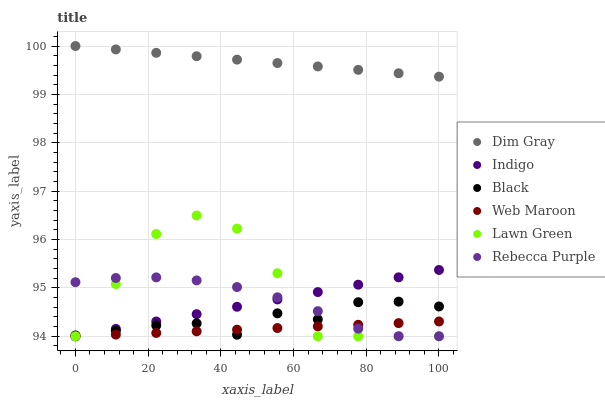Does Web Maroon have the minimum area under the curve?
Answer yes or no. Yes. Does Dim Gray have the maximum area under the curve?
Answer yes or no. Yes. Does Indigo have the minimum area under the curve?
Answer yes or no. No. Does Indigo have the maximum area under the curve?
Answer yes or no. No. Is Indigo the smoothest?
Answer yes or no. Yes. Is Lawn Green the roughest?
Answer yes or no. Yes. Is Dim Gray the smoothest?
Answer yes or no. No. Is Dim Gray the roughest?
Answer yes or no. No. Does Lawn Green have the lowest value?
Answer yes or no. Yes. Does Dim Gray have the lowest value?
Answer yes or no. No. Does Dim Gray have the highest value?
Answer yes or no. Yes. Does Indigo have the highest value?
Answer yes or no. No. Is Lawn Green less than Dim Gray?
Answer yes or no. Yes. Is Dim Gray greater than Lawn Green?
Answer yes or no. Yes. Does Black intersect Lawn Green?
Answer yes or no. Yes. Is Black less than Lawn Green?
Answer yes or no. No. Is Black greater than Lawn Green?
Answer yes or no. No. Does Lawn Green intersect Dim Gray?
Answer yes or no. No. 